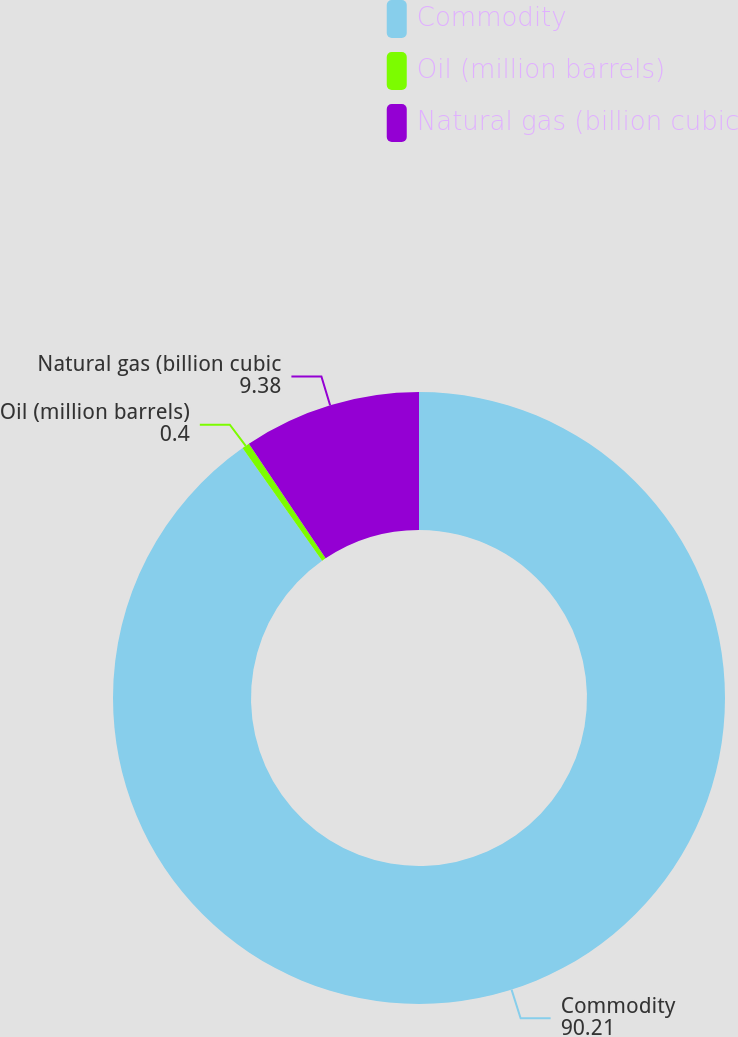Convert chart to OTSL. <chart><loc_0><loc_0><loc_500><loc_500><pie_chart><fcel>Commodity<fcel>Oil (million barrels)<fcel>Natural gas (billion cubic<nl><fcel>90.21%<fcel>0.4%<fcel>9.38%<nl></chart> 